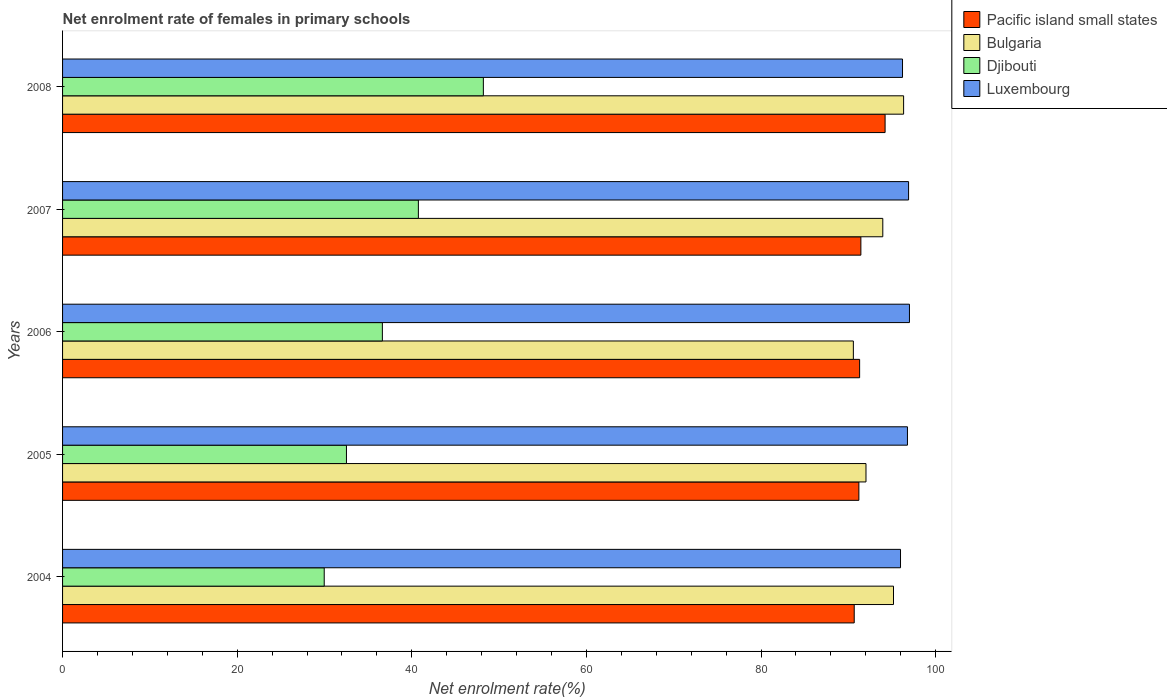How many different coloured bars are there?
Ensure brevity in your answer.  4. Are the number of bars per tick equal to the number of legend labels?
Provide a succinct answer. Yes. Are the number of bars on each tick of the Y-axis equal?
Keep it short and to the point. Yes. How many bars are there on the 1st tick from the top?
Your answer should be very brief. 4. What is the label of the 1st group of bars from the top?
Provide a short and direct response. 2008. In how many cases, is the number of bars for a given year not equal to the number of legend labels?
Your answer should be very brief. 0. What is the net enrolment rate of females in primary schools in Luxembourg in 2005?
Your response must be concise. 96.77. Across all years, what is the maximum net enrolment rate of females in primary schools in Bulgaria?
Provide a succinct answer. 96.33. Across all years, what is the minimum net enrolment rate of females in primary schools in Pacific island small states?
Offer a very short reply. 90.67. In which year was the net enrolment rate of females in primary schools in Pacific island small states maximum?
Your response must be concise. 2008. In which year was the net enrolment rate of females in primary schools in Luxembourg minimum?
Your answer should be compact. 2004. What is the total net enrolment rate of females in primary schools in Djibouti in the graph?
Your response must be concise. 188.06. What is the difference between the net enrolment rate of females in primary schools in Luxembourg in 2006 and that in 2008?
Your answer should be compact. 0.8. What is the difference between the net enrolment rate of females in primary schools in Djibouti in 2005 and the net enrolment rate of females in primary schools in Luxembourg in 2007?
Offer a terse response. -64.38. What is the average net enrolment rate of females in primary schools in Luxembourg per year?
Offer a very short reply. 96.57. In the year 2008, what is the difference between the net enrolment rate of females in primary schools in Luxembourg and net enrolment rate of females in primary schools in Bulgaria?
Make the answer very short. -0.12. In how many years, is the net enrolment rate of females in primary schools in Pacific island small states greater than 92 %?
Provide a succinct answer. 1. What is the ratio of the net enrolment rate of females in primary schools in Bulgaria in 2005 to that in 2006?
Make the answer very short. 1.02. Is the net enrolment rate of females in primary schools in Pacific island small states in 2006 less than that in 2008?
Make the answer very short. Yes. Is the difference between the net enrolment rate of females in primary schools in Luxembourg in 2005 and 2006 greater than the difference between the net enrolment rate of females in primary schools in Bulgaria in 2005 and 2006?
Provide a short and direct response. No. What is the difference between the highest and the second highest net enrolment rate of females in primary schools in Luxembourg?
Ensure brevity in your answer.  0.1. What is the difference between the highest and the lowest net enrolment rate of females in primary schools in Luxembourg?
Give a very brief answer. 1.02. In how many years, is the net enrolment rate of females in primary schools in Pacific island small states greater than the average net enrolment rate of females in primary schools in Pacific island small states taken over all years?
Give a very brief answer. 1. What does the 2nd bar from the top in 2004 represents?
Provide a succinct answer. Djibouti. What does the 1st bar from the bottom in 2005 represents?
Ensure brevity in your answer.  Pacific island small states. How many bars are there?
Give a very brief answer. 20. What is the difference between two consecutive major ticks on the X-axis?
Your answer should be compact. 20. How are the legend labels stacked?
Offer a terse response. Vertical. What is the title of the graph?
Offer a terse response. Net enrolment rate of females in primary schools. Does "Iran" appear as one of the legend labels in the graph?
Offer a very short reply. No. What is the label or title of the X-axis?
Your answer should be very brief. Net enrolment rate(%). What is the Net enrolment rate(%) in Pacific island small states in 2004?
Your answer should be very brief. 90.67. What is the Net enrolment rate(%) in Bulgaria in 2004?
Offer a very short reply. 95.17. What is the Net enrolment rate(%) of Djibouti in 2004?
Offer a terse response. 29.97. What is the Net enrolment rate(%) in Luxembourg in 2004?
Give a very brief answer. 95.97. What is the Net enrolment rate(%) in Pacific island small states in 2005?
Provide a succinct answer. 91.2. What is the Net enrolment rate(%) in Bulgaria in 2005?
Your answer should be compact. 92.02. What is the Net enrolment rate(%) in Djibouti in 2005?
Provide a short and direct response. 32.51. What is the Net enrolment rate(%) in Luxembourg in 2005?
Give a very brief answer. 96.77. What is the Net enrolment rate(%) of Pacific island small states in 2006?
Ensure brevity in your answer.  91.29. What is the Net enrolment rate(%) in Bulgaria in 2006?
Keep it short and to the point. 90.57. What is the Net enrolment rate(%) of Djibouti in 2006?
Offer a very short reply. 36.63. What is the Net enrolment rate(%) in Luxembourg in 2006?
Make the answer very short. 97. What is the Net enrolment rate(%) of Pacific island small states in 2007?
Offer a very short reply. 91.43. What is the Net enrolment rate(%) in Bulgaria in 2007?
Make the answer very short. 93.94. What is the Net enrolment rate(%) of Djibouti in 2007?
Provide a succinct answer. 40.75. What is the Net enrolment rate(%) of Luxembourg in 2007?
Ensure brevity in your answer.  96.9. What is the Net enrolment rate(%) of Pacific island small states in 2008?
Offer a very short reply. 94.21. What is the Net enrolment rate(%) in Bulgaria in 2008?
Provide a short and direct response. 96.33. What is the Net enrolment rate(%) of Djibouti in 2008?
Offer a very short reply. 48.19. What is the Net enrolment rate(%) in Luxembourg in 2008?
Keep it short and to the point. 96.2. Across all years, what is the maximum Net enrolment rate(%) of Pacific island small states?
Offer a very short reply. 94.21. Across all years, what is the maximum Net enrolment rate(%) of Bulgaria?
Your answer should be compact. 96.33. Across all years, what is the maximum Net enrolment rate(%) in Djibouti?
Provide a succinct answer. 48.19. Across all years, what is the maximum Net enrolment rate(%) in Luxembourg?
Keep it short and to the point. 97. Across all years, what is the minimum Net enrolment rate(%) of Pacific island small states?
Provide a short and direct response. 90.67. Across all years, what is the minimum Net enrolment rate(%) of Bulgaria?
Make the answer very short. 90.57. Across all years, what is the minimum Net enrolment rate(%) in Djibouti?
Offer a terse response. 29.97. Across all years, what is the minimum Net enrolment rate(%) in Luxembourg?
Make the answer very short. 95.97. What is the total Net enrolment rate(%) of Pacific island small states in the graph?
Keep it short and to the point. 458.8. What is the total Net enrolment rate(%) of Bulgaria in the graph?
Your answer should be very brief. 468.03. What is the total Net enrolment rate(%) in Djibouti in the graph?
Make the answer very short. 188.06. What is the total Net enrolment rate(%) of Luxembourg in the graph?
Provide a short and direct response. 482.83. What is the difference between the Net enrolment rate(%) in Pacific island small states in 2004 and that in 2005?
Ensure brevity in your answer.  -0.53. What is the difference between the Net enrolment rate(%) in Bulgaria in 2004 and that in 2005?
Offer a very short reply. 3.15. What is the difference between the Net enrolment rate(%) of Djibouti in 2004 and that in 2005?
Keep it short and to the point. -2.55. What is the difference between the Net enrolment rate(%) of Luxembourg in 2004 and that in 2005?
Your answer should be compact. -0.79. What is the difference between the Net enrolment rate(%) in Pacific island small states in 2004 and that in 2006?
Ensure brevity in your answer.  -0.62. What is the difference between the Net enrolment rate(%) in Bulgaria in 2004 and that in 2006?
Keep it short and to the point. 4.6. What is the difference between the Net enrolment rate(%) of Djibouti in 2004 and that in 2006?
Provide a succinct answer. -6.66. What is the difference between the Net enrolment rate(%) in Luxembourg in 2004 and that in 2006?
Your response must be concise. -1.02. What is the difference between the Net enrolment rate(%) in Pacific island small states in 2004 and that in 2007?
Ensure brevity in your answer.  -0.76. What is the difference between the Net enrolment rate(%) of Bulgaria in 2004 and that in 2007?
Keep it short and to the point. 1.23. What is the difference between the Net enrolment rate(%) in Djibouti in 2004 and that in 2007?
Offer a terse response. -10.78. What is the difference between the Net enrolment rate(%) in Luxembourg in 2004 and that in 2007?
Make the answer very short. -0.92. What is the difference between the Net enrolment rate(%) in Pacific island small states in 2004 and that in 2008?
Provide a short and direct response. -3.54. What is the difference between the Net enrolment rate(%) of Bulgaria in 2004 and that in 2008?
Your answer should be very brief. -1.16. What is the difference between the Net enrolment rate(%) in Djibouti in 2004 and that in 2008?
Offer a very short reply. -18.23. What is the difference between the Net enrolment rate(%) of Luxembourg in 2004 and that in 2008?
Ensure brevity in your answer.  -0.23. What is the difference between the Net enrolment rate(%) of Pacific island small states in 2005 and that in 2006?
Your response must be concise. -0.09. What is the difference between the Net enrolment rate(%) of Bulgaria in 2005 and that in 2006?
Keep it short and to the point. 1.45. What is the difference between the Net enrolment rate(%) in Djibouti in 2005 and that in 2006?
Your answer should be compact. -4.12. What is the difference between the Net enrolment rate(%) in Luxembourg in 2005 and that in 2006?
Your answer should be very brief. -0.23. What is the difference between the Net enrolment rate(%) in Pacific island small states in 2005 and that in 2007?
Your answer should be compact. -0.23. What is the difference between the Net enrolment rate(%) in Bulgaria in 2005 and that in 2007?
Provide a succinct answer. -1.93. What is the difference between the Net enrolment rate(%) in Djibouti in 2005 and that in 2007?
Offer a terse response. -8.24. What is the difference between the Net enrolment rate(%) in Luxembourg in 2005 and that in 2007?
Make the answer very short. -0.13. What is the difference between the Net enrolment rate(%) of Pacific island small states in 2005 and that in 2008?
Provide a short and direct response. -3. What is the difference between the Net enrolment rate(%) of Bulgaria in 2005 and that in 2008?
Make the answer very short. -4.31. What is the difference between the Net enrolment rate(%) of Djibouti in 2005 and that in 2008?
Your answer should be very brief. -15.68. What is the difference between the Net enrolment rate(%) of Luxembourg in 2005 and that in 2008?
Make the answer very short. 0.57. What is the difference between the Net enrolment rate(%) of Pacific island small states in 2006 and that in 2007?
Your answer should be very brief. -0.14. What is the difference between the Net enrolment rate(%) in Bulgaria in 2006 and that in 2007?
Make the answer very short. -3.37. What is the difference between the Net enrolment rate(%) of Djibouti in 2006 and that in 2007?
Offer a very short reply. -4.12. What is the difference between the Net enrolment rate(%) of Luxembourg in 2006 and that in 2007?
Keep it short and to the point. 0.1. What is the difference between the Net enrolment rate(%) in Pacific island small states in 2006 and that in 2008?
Provide a succinct answer. -2.92. What is the difference between the Net enrolment rate(%) in Bulgaria in 2006 and that in 2008?
Your answer should be very brief. -5.76. What is the difference between the Net enrolment rate(%) in Djibouti in 2006 and that in 2008?
Offer a very short reply. -11.57. What is the difference between the Net enrolment rate(%) of Luxembourg in 2006 and that in 2008?
Provide a short and direct response. 0.8. What is the difference between the Net enrolment rate(%) of Pacific island small states in 2007 and that in 2008?
Provide a short and direct response. -2.77. What is the difference between the Net enrolment rate(%) in Bulgaria in 2007 and that in 2008?
Your response must be concise. -2.38. What is the difference between the Net enrolment rate(%) in Djibouti in 2007 and that in 2008?
Your answer should be compact. -7.44. What is the difference between the Net enrolment rate(%) of Luxembourg in 2007 and that in 2008?
Keep it short and to the point. 0.69. What is the difference between the Net enrolment rate(%) in Pacific island small states in 2004 and the Net enrolment rate(%) in Bulgaria in 2005?
Your answer should be very brief. -1.35. What is the difference between the Net enrolment rate(%) of Pacific island small states in 2004 and the Net enrolment rate(%) of Djibouti in 2005?
Your response must be concise. 58.16. What is the difference between the Net enrolment rate(%) in Pacific island small states in 2004 and the Net enrolment rate(%) in Luxembourg in 2005?
Provide a short and direct response. -6.1. What is the difference between the Net enrolment rate(%) in Bulgaria in 2004 and the Net enrolment rate(%) in Djibouti in 2005?
Your answer should be very brief. 62.66. What is the difference between the Net enrolment rate(%) of Bulgaria in 2004 and the Net enrolment rate(%) of Luxembourg in 2005?
Give a very brief answer. -1.6. What is the difference between the Net enrolment rate(%) of Djibouti in 2004 and the Net enrolment rate(%) of Luxembourg in 2005?
Provide a short and direct response. -66.8. What is the difference between the Net enrolment rate(%) in Pacific island small states in 2004 and the Net enrolment rate(%) in Bulgaria in 2006?
Provide a succinct answer. 0.1. What is the difference between the Net enrolment rate(%) in Pacific island small states in 2004 and the Net enrolment rate(%) in Djibouti in 2006?
Your response must be concise. 54.04. What is the difference between the Net enrolment rate(%) in Pacific island small states in 2004 and the Net enrolment rate(%) in Luxembourg in 2006?
Make the answer very short. -6.33. What is the difference between the Net enrolment rate(%) of Bulgaria in 2004 and the Net enrolment rate(%) of Djibouti in 2006?
Your answer should be very brief. 58.54. What is the difference between the Net enrolment rate(%) of Bulgaria in 2004 and the Net enrolment rate(%) of Luxembourg in 2006?
Your answer should be compact. -1.83. What is the difference between the Net enrolment rate(%) of Djibouti in 2004 and the Net enrolment rate(%) of Luxembourg in 2006?
Give a very brief answer. -67.03. What is the difference between the Net enrolment rate(%) in Pacific island small states in 2004 and the Net enrolment rate(%) in Bulgaria in 2007?
Keep it short and to the point. -3.27. What is the difference between the Net enrolment rate(%) in Pacific island small states in 2004 and the Net enrolment rate(%) in Djibouti in 2007?
Your answer should be compact. 49.92. What is the difference between the Net enrolment rate(%) in Pacific island small states in 2004 and the Net enrolment rate(%) in Luxembourg in 2007?
Ensure brevity in your answer.  -6.23. What is the difference between the Net enrolment rate(%) in Bulgaria in 2004 and the Net enrolment rate(%) in Djibouti in 2007?
Offer a very short reply. 54.42. What is the difference between the Net enrolment rate(%) of Bulgaria in 2004 and the Net enrolment rate(%) of Luxembourg in 2007?
Offer a very short reply. -1.73. What is the difference between the Net enrolment rate(%) in Djibouti in 2004 and the Net enrolment rate(%) in Luxembourg in 2007?
Your response must be concise. -66.93. What is the difference between the Net enrolment rate(%) in Pacific island small states in 2004 and the Net enrolment rate(%) in Bulgaria in 2008?
Offer a terse response. -5.66. What is the difference between the Net enrolment rate(%) in Pacific island small states in 2004 and the Net enrolment rate(%) in Djibouti in 2008?
Keep it short and to the point. 42.47. What is the difference between the Net enrolment rate(%) of Pacific island small states in 2004 and the Net enrolment rate(%) of Luxembourg in 2008?
Offer a very short reply. -5.53. What is the difference between the Net enrolment rate(%) of Bulgaria in 2004 and the Net enrolment rate(%) of Djibouti in 2008?
Offer a terse response. 46.97. What is the difference between the Net enrolment rate(%) in Bulgaria in 2004 and the Net enrolment rate(%) in Luxembourg in 2008?
Make the answer very short. -1.03. What is the difference between the Net enrolment rate(%) in Djibouti in 2004 and the Net enrolment rate(%) in Luxembourg in 2008?
Keep it short and to the point. -66.23. What is the difference between the Net enrolment rate(%) of Pacific island small states in 2005 and the Net enrolment rate(%) of Bulgaria in 2006?
Provide a succinct answer. 0.63. What is the difference between the Net enrolment rate(%) in Pacific island small states in 2005 and the Net enrolment rate(%) in Djibouti in 2006?
Your answer should be very brief. 54.57. What is the difference between the Net enrolment rate(%) of Pacific island small states in 2005 and the Net enrolment rate(%) of Luxembourg in 2006?
Offer a very short reply. -5.79. What is the difference between the Net enrolment rate(%) in Bulgaria in 2005 and the Net enrolment rate(%) in Djibouti in 2006?
Provide a short and direct response. 55.39. What is the difference between the Net enrolment rate(%) of Bulgaria in 2005 and the Net enrolment rate(%) of Luxembourg in 2006?
Keep it short and to the point. -4.98. What is the difference between the Net enrolment rate(%) in Djibouti in 2005 and the Net enrolment rate(%) in Luxembourg in 2006?
Keep it short and to the point. -64.48. What is the difference between the Net enrolment rate(%) in Pacific island small states in 2005 and the Net enrolment rate(%) in Bulgaria in 2007?
Your response must be concise. -2.74. What is the difference between the Net enrolment rate(%) in Pacific island small states in 2005 and the Net enrolment rate(%) in Djibouti in 2007?
Offer a terse response. 50.45. What is the difference between the Net enrolment rate(%) of Pacific island small states in 2005 and the Net enrolment rate(%) of Luxembourg in 2007?
Your answer should be compact. -5.69. What is the difference between the Net enrolment rate(%) of Bulgaria in 2005 and the Net enrolment rate(%) of Djibouti in 2007?
Offer a terse response. 51.27. What is the difference between the Net enrolment rate(%) of Bulgaria in 2005 and the Net enrolment rate(%) of Luxembourg in 2007?
Your answer should be compact. -4.88. What is the difference between the Net enrolment rate(%) in Djibouti in 2005 and the Net enrolment rate(%) in Luxembourg in 2007?
Ensure brevity in your answer.  -64.38. What is the difference between the Net enrolment rate(%) of Pacific island small states in 2005 and the Net enrolment rate(%) of Bulgaria in 2008?
Offer a very short reply. -5.12. What is the difference between the Net enrolment rate(%) in Pacific island small states in 2005 and the Net enrolment rate(%) in Djibouti in 2008?
Your answer should be very brief. 43.01. What is the difference between the Net enrolment rate(%) in Pacific island small states in 2005 and the Net enrolment rate(%) in Luxembourg in 2008?
Provide a short and direct response. -5. What is the difference between the Net enrolment rate(%) of Bulgaria in 2005 and the Net enrolment rate(%) of Djibouti in 2008?
Offer a very short reply. 43.82. What is the difference between the Net enrolment rate(%) of Bulgaria in 2005 and the Net enrolment rate(%) of Luxembourg in 2008?
Offer a terse response. -4.18. What is the difference between the Net enrolment rate(%) in Djibouti in 2005 and the Net enrolment rate(%) in Luxembourg in 2008?
Your answer should be very brief. -63.69. What is the difference between the Net enrolment rate(%) of Pacific island small states in 2006 and the Net enrolment rate(%) of Bulgaria in 2007?
Give a very brief answer. -2.65. What is the difference between the Net enrolment rate(%) of Pacific island small states in 2006 and the Net enrolment rate(%) of Djibouti in 2007?
Your answer should be compact. 50.54. What is the difference between the Net enrolment rate(%) in Pacific island small states in 2006 and the Net enrolment rate(%) in Luxembourg in 2007?
Offer a very short reply. -5.61. What is the difference between the Net enrolment rate(%) of Bulgaria in 2006 and the Net enrolment rate(%) of Djibouti in 2007?
Offer a terse response. 49.82. What is the difference between the Net enrolment rate(%) in Bulgaria in 2006 and the Net enrolment rate(%) in Luxembourg in 2007?
Your response must be concise. -6.33. What is the difference between the Net enrolment rate(%) of Djibouti in 2006 and the Net enrolment rate(%) of Luxembourg in 2007?
Provide a succinct answer. -60.27. What is the difference between the Net enrolment rate(%) in Pacific island small states in 2006 and the Net enrolment rate(%) in Bulgaria in 2008?
Provide a succinct answer. -5.04. What is the difference between the Net enrolment rate(%) in Pacific island small states in 2006 and the Net enrolment rate(%) in Djibouti in 2008?
Ensure brevity in your answer.  43.1. What is the difference between the Net enrolment rate(%) of Pacific island small states in 2006 and the Net enrolment rate(%) of Luxembourg in 2008?
Provide a short and direct response. -4.91. What is the difference between the Net enrolment rate(%) in Bulgaria in 2006 and the Net enrolment rate(%) in Djibouti in 2008?
Provide a succinct answer. 42.38. What is the difference between the Net enrolment rate(%) of Bulgaria in 2006 and the Net enrolment rate(%) of Luxembourg in 2008?
Ensure brevity in your answer.  -5.63. What is the difference between the Net enrolment rate(%) in Djibouti in 2006 and the Net enrolment rate(%) in Luxembourg in 2008?
Keep it short and to the point. -59.57. What is the difference between the Net enrolment rate(%) of Pacific island small states in 2007 and the Net enrolment rate(%) of Bulgaria in 2008?
Your answer should be compact. -4.89. What is the difference between the Net enrolment rate(%) of Pacific island small states in 2007 and the Net enrolment rate(%) of Djibouti in 2008?
Provide a short and direct response. 43.24. What is the difference between the Net enrolment rate(%) in Pacific island small states in 2007 and the Net enrolment rate(%) in Luxembourg in 2008?
Make the answer very short. -4.77. What is the difference between the Net enrolment rate(%) of Bulgaria in 2007 and the Net enrolment rate(%) of Djibouti in 2008?
Keep it short and to the point. 45.75. What is the difference between the Net enrolment rate(%) in Bulgaria in 2007 and the Net enrolment rate(%) in Luxembourg in 2008?
Offer a very short reply. -2.26. What is the difference between the Net enrolment rate(%) in Djibouti in 2007 and the Net enrolment rate(%) in Luxembourg in 2008?
Keep it short and to the point. -55.45. What is the average Net enrolment rate(%) in Pacific island small states per year?
Offer a very short reply. 91.76. What is the average Net enrolment rate(%) of Bulgaria per year?
Keep it short and to the point. 93.61. What is the average Net enrolment rate(%) of Djibouti per year?
Your answer should be very brief. 37.61. What is the average Net enrolment rate(%) of Luxembourg per year?
Provide a short and direct response. 96.57. In the year 2004, what is the difference between the Net enrolment rate(%) of Pacific island small states and Net enrolment rate(%) of Bulgaria?
Your answer should be very brief. -4.5. In the year 2004, what is the difference between the Net enrolment rate(%) in Pacific island small states and Net enrolment rate(%) in Djibouti?
Your answer should be very brief. 60.7. In the year 2004, what is the difference between the Net enrolment rate(%) in Pacific island small states and Net enrolment rate(%) in Luxembourg?
Make the answer very short. -5.3. In the year 2004, what is the difference between the Net enrolment rate(%) of Bulgaria and Net enrolment rate(%) of Djibouti?
Make the answer very short. 65.2. In the year 2004, what is the difference between the Net enrolment rate(%) in Bulgaria and Net enrolment rate(%) in Luxembourg?
Offer a very short reply. -0.8. In the year 2004, what is the difference between the Net enrolment rate(%) of Djibouti and Net enrolment rate(%) of Luxembourg?
Offer a terse response. -66. In the year 2005, what is the difference between the Net enrolment rate(%) in Pacific island small states and Net enrolment rate(%) in Bulgaria?
Your answer should be very brief. -0.81. In the year 2005, what is the difference between the Net enrolment rate(%) in Pacific island small states and Net enrolment rate(%) in Djibouti?
Provide a short and direct response. 58.69. In the year 2005, what is the difference between the Net enrolment rate(%) of Pacific island small states and Net enrolment rate(%) of Luxembourg?
Your response must be concise. -5.56. In the year 2005, what is the difference between the Net enrolment rate(%) in Bulgaria and Net enrolment rate(%) in Djibouti?
Ensure brevity in your answer.  59.5. In the year 2005, what is the difference between the Net enrolment rate(%) of Bulgaria and Net enrolment rate(%) of Luxembourg?
Offer a very short reply. -4.75. In the year 2005, what is the difference between the Net enrolment rate(%) in Djibouti and Net enrolment rate(%) in Luxembourg?
Ensure brevity in your answer.  -64.25. In the year 2006, what is the difference between the Net enrolment rate(%) in Pacific island small states and Net enrolment rate(%) in Bulgaria?
Your answer should be very brief. 0.72. In the year 2006, what is the difference between the Net enrolment rate(%) of Pacific island small states and Net enrolment rate(%) of Djibouti?
Provide a short and direct response. 54.66. In the year 2006, what is the difference between the Net enrolment rate(%) of Pacific island small states and Net enrolment rate(%) of Luxembourg?
Offer a very short reply. -5.71. In the year 2006, what is the difference between the Net enrolment rate(%) in Bulgaria and Net enrolment rate(%) in Djibouti?
Keep it short and to the point. 53.94. In the year 2006, what is the difference between the Net enrolment rate(%) of Bulgaria and Net enrolment rate(%) of Luxembourg?
Keep it short and to the point. -6.43. In the year 2006, what is the difference between the Net enrolment rate(%) in Djibouti and Net enrolment rate(%) in Luxembourg?
Offer a very short reply. -60.37. In the year 2007, what is the difference between the Net enrolment rate(%) of Pacific island small states and Net enrolment rate(%) of Bulgaria?
Offer a very short reply. -2.51. In the year 2007, what is the difference between the Net enrolment rate(%) of Pacific island small states and Net enrolment rate(%) of Djibouti?
Offer a terse response. 50.68. In the year 2007, what is the difference between the Net enrolment rate(%) in Pacific island small states and Net enrolment rate(%) in Luxembourg?
Your answer should be compact. -5.46. In the year 2007, what is the difference between the Net enrolment rate(%) of Bulgaria and Net enrolment rate(%) of Djibouti?
Offer a very short reply. 53.19. In the year 2007, what is the difference between the Net enrolment rate(%) of Bulgaria and Net enrolment rate(%) of Luxembourg?
Your response must be concise. -2.95. In the year 2007, what is the difference between the Net enrolment rate(%) in Djibouti and Net enrolment rate(%) in Luxembourg?
Ensure brevity in your answer.  -56.15. In the year 2008, what is the difference between the Net enrolment rate(%) in Pacific island small states and Net enrolment rate(%) in Bulgaria?
Make the answer very short. -2.12. In the year 2008, what is the difference between the Net enrolment rate(%) of Pacific island small states and Net enrolment rate(%) of Djibouti?
Offer a terse response. 46.01. In the year 2008, what is the difference between the Net enrolment rate(%) of Pacific island small states and Net enrolment rate(%) of Luxembourg?
Your answer should be compact. -2. In the year 2008, what is the difference between the Net enrolment rate(%) of Bulgaria and Net enrolment rate(%) of Djibouti?
Keep it short and to the point. 48.13. In the year 2008, what is the difference between the Net enrolment rate(%) in Bulgaria and Net enrolment rate(%) in Luxembourg?
Provide a short and direct response. 0.12. In the year 2008, what is the difference between the Net enrolment rate(%) in Djibouti and Net enrolment rate(%) in Luxembourg?
Offer a very short reply. -48.01. What is the ratio of the Net enrolment rate(%) in Bulgaria in 2004 to that in 2005?
Offer a terse response. 1.03. What is the ratio of the Net enrolment rate(%) in Djibouti in 2004 to that in 2005?
Make the answer very short. 0.92. What is the ratio of the Net enrolment rate(%) of Luxembourg in 2004 to that in 2005?
Give a very brief answer. 0.99. What is the ratio of the Net enrolment rate(%) in Bulgaria in 2004 to that in 2006?
Your response must be concise. 1.05. What is the ratio of the Net enrolment rate(%) of Djibouti in 2004 to that in 2006?
Ensure brevity in your answer.  0.82. What is the ratio of the Net enrolment rate(%) of Bulgaria in 2004 to that in 2007?
Provide a short and direct response. 1.01. What is the ratio of the Net enrolment rate(%) in Djibouti in 2004 to that in 2007?
Your response must be concise. 0.74. What is the ratio of the Net enrolment rate(%) of Luxembourg in 2004 to that in 2007?
Offer a very short reply. 0.99. What is the ratio of the Net enrolment rate(%) in Pacific island small states in 2004 to that in 2008?
Give a very brief answer. 0.96. What is the ratio of the Net enrolment rate(%) in Bulgaria in 2004 to that in 2008?
Your answer should be compact. 0.99. What is the ratio of the Net enrolment rate(%) in Djibouti in 2004 to that in 2008?
Offer a very short reply. 0.62. What is the ratio of the Net enrolment rate(%) in Pacific island small states in 2005 to that in 2006?
Your response must be concise. 1. What is the ratio of the Net enrolment rate(%) in Djibouti in 2005 to that in 2006?
Give a very brief answer. 0.89. What is the ratio of the Net enrolment rate(%) of Luxembourg in 2005 to that in 2006?
Your answer should be compact. 1. What is the ratio of the Net enrolment rate(%) in Pacific island small states in 2005 to that in 2007?
Offer a terse response. 1. What is the ratio of the Net enrolment rate(%) of Bulgaria in 2005 to that in 2007?
Ensure brevity in your answer.  0.98. What is the ratio of the Net enrolment rate(%) of Djibouti in 2005 to that in 2007?
Your answer should be compact. 0.8. What is the ratio of the Net enrolment rate(%) in Pacific island small states in 2005 to that in 2008?
Keep it short and to the point. 0.97. What is the ratio of the Net enrolment rate(%) in Bulgaria in 2005 to that in 2008?
Offer a very short reply. 0.96. What is the ratio of the Net enrolment rate(%) in Djibouti in 2005 to that in 2008?
Offer a very short reply. 0.67. What is the ratio of the Net enrolment rate(%) of Luxembourg in 2005 to that in 2008?
Your answer should be very brief. 1.01. What is the ratio of the Net enrolment rate(%) in Pacific island small states in 2006 to that in 2007?
Give a very brief answer. 1. What is the ratio of the Net enrolment rate(%) in Bulgaria in 2006 to that in 2007?
Give a very brief answer. 0.96. What is the ratio of the Net enrolment rate(%) in Djibouti in 2006 to that in 2007?
Provide a short and direct response. 0.9. What is the ratio of the Net enrolment rate(%) of Bulgaria in 2006 to that in 2008?
Make the answer very short. 0.94. What is the ratio of the Net enrolment rate(%) in Djibouti in 2006 to that in 2008?
Ensure brevity in your answer.  0.76. What is the ratio of the Net enrolment rate(%) in Luxembourg in 2006 to that in 2008?
Give a very brief answer. 1.01. What is the ratio of the Net enrolment rate(%) in Pacific island small states in 2007 to that in 2008?
Offer a very short reply. 0.97. What is the ratio of the Net enrolment rate(%) in Bulgaria in 2007 to that in 2008?
Provide a short and direct response. 0.98. What is the ratio of the Net enrolment rate(%) of Djibouti in 2007 to that in 2008?
Your answer should be compact. 0.85. What is the difference between the highest and the second highest Net enrolment rate(%) in Pacific island small states?
Offer a terse response. 2.77. What is the difference between the highest and the second highest Net enrolment rate(%) in Bulgaria?
Make the answer very short. 1.16. What is the difference between the highest and the second highest Net enrolment rate(%) of Djibouti?
Provide a succinct answer. 7.44. What is the difference between the highest and the second highest Net enrolment rate(%) in Luxembourg?
Your answer should be very brief. 0.1. What is the difference between the highest and the lowest Net enrolment rate(%) in Pacific island small states?
Give a very brief answer. 3.54. What is the difference between the highest and the lowest Net enrolment rate(%) in Bulgaria?
Keep it short and to the point. 5.76. What is the difference between the highest and the lowest Net enrolment rate(%) in Djibouti?
Your answer should be compact. 18.23. What is the difference between the highest and the lowest Net enrolment rate(%) of Luxembourg?
Provide a short and direct response. 1.02. 